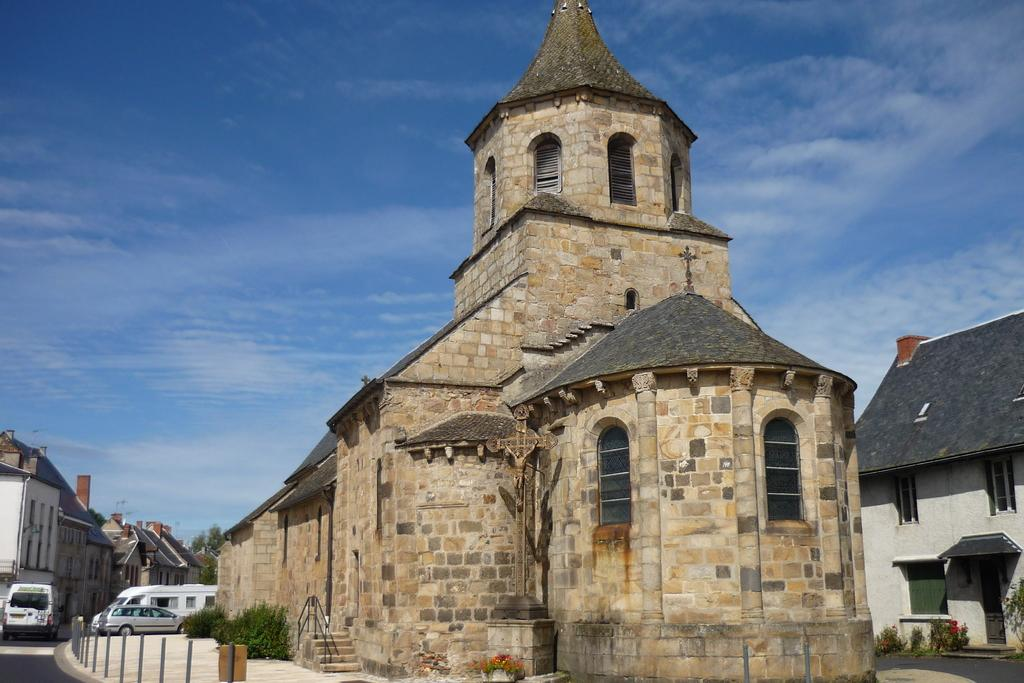What is located in the center of the image? There are buildings in the center of the image. What can be seen on the left side of the image? There are vehicles on the left side of the image. What type of vegetation is present in the image? There are bushes in the image. What is visible at the top of the image? The sky is visible at the top of the image. How many tails can be seen on the bushes in the image? There are no tails present on the bushes in the image. What need is being fulfilled by the vehicles in the image? The image does not provide information about the need being fulfilled by the vehicles. 